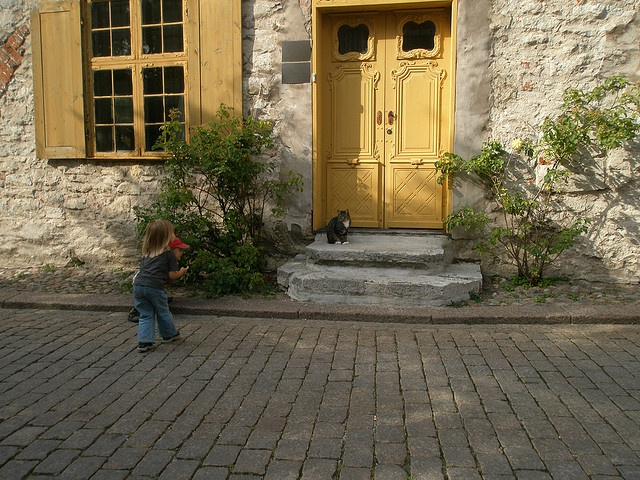Describe the objects in this image and their specific colors. I can see people in darkgray, black, gray, blue, and maroon tones and cat in darkgray, black, olive, and gray tones in this image. 